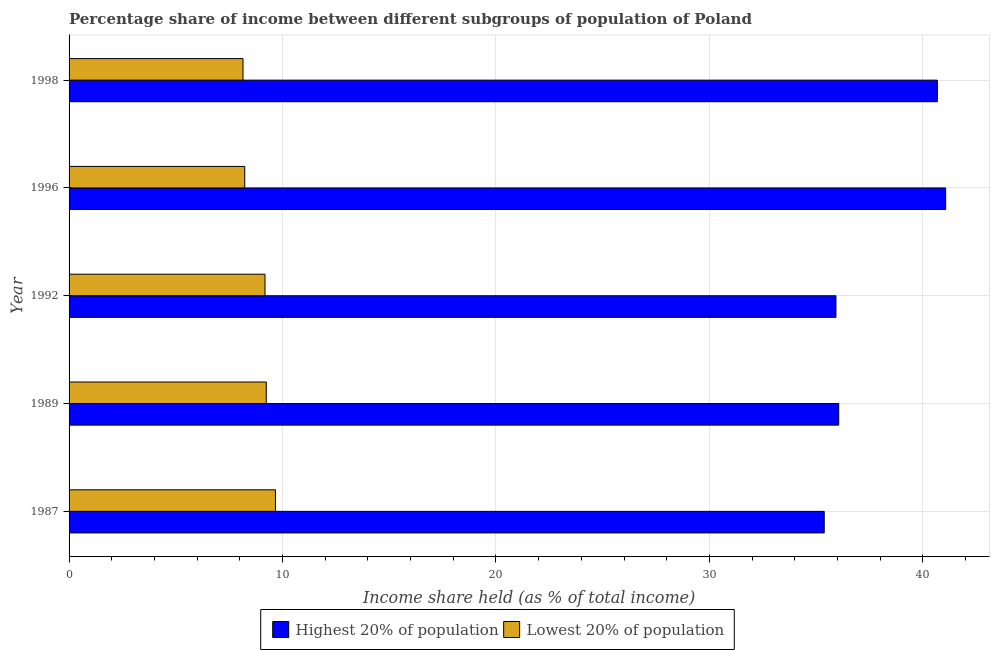How many different coloured bars are there?
Make the answer very short. 2. Are the number of bars on each tick of the Y-axis equal?
Keep it short and to the point. Yes. How many bars are there on the 1st tick from the top?
Your answer should be compact. 2. How many bars are there on the 3rd tick from the bottom?
Your answer should be very brief. 2. What is the income share held by highest 20% of the population in 1987?
Give a very brief answer. 35.38. Across all years, what is the maximum income share held by lowest 20% of the population?
Offer a very short reply. 9.67. Across all years, what is the minimum income share held by highest 20% of the population?
Your answer should be very brief. 35.38. What is the total income share held by highest 20% of the population in the graph?
Make the answer very short. 189.12. What is the difference between the income share held by highest 20% of the population in 1998 and the income share held by lowest 20% of the population in 1987?
Provide a short and direct response. 31.01. What is the average income share held by highest 20% of the population per year?
Your response must be concise. 37.82. In the year 1992, what is the difference between the income share held by highest 20% of the population and income share held by lowest 20% of the population?
Offer a very short reply. 26.75. Is the income share held by highest 20% of the population in 1987 less than that in 1998?
Make the answer very short. Yes. What is the difference between the highest and the second highest income share held by highest 20% of the population?
Give a very brief answer. 0.39. What is the difference between the highest and the lowest income share held by lowest 20% of the population?
Your answer should be compact. 1.52. In how many years, is the income share held by highest 20% of the population greater than the average income share held by highest 20% of the population taken over all years?
Ensure brevity in your answer.  2. What does the 1st bar from the top in 1992 represents?
Your response must be concise. Lowest 20% of population. What does the 2nd bar from the bottom in 1989 represents?
Make the answer very short. Lowest 20% of population. How many bars are there?
Give a very brief answer. 10. How many years are there in the graph?
Provide a succinct answer. 5. Where does the legend appear in the graph?
Ensure brevity in your answer.  Bottom center. How many legend labels are there?
Provide a short and direct response. 2. How are the legend labels stacked?
Your answer should be compact. Horizontal. What is the title of the graph?
Offer a terse response. Percentage share of income between different subgroups of population of Poland. Does "Travel services" appear as one of the legend labels in the graph?
Give a very brief answer. No. What is the label or title of the X-axis?
Offer a terse response. Income share held (as % of total income). What is the Income share held (as % of total income) of Highest 20% of population in 1987?
Make the answer very short. 35.38. What is the Income share held (as % of total income) in Lowest 20% of population in 1987?
Keep it short and to the point. 9.67. What is the Income share held (as % of total income) in Highest 20% of population in 1989?
Give a very brief answer. 36.06. What is the Income share held (as % of total income) in Lowest 20% of population in 1989?
Offer a terse response. 9.24. What is the Income share held (as % of total income) in Highest 20% of population in 1992?
Provide a succinct answer. 35.93. What is the Income share held (as % of total income) of Lowest 20% of population in 1992?
Give a very brief answer. 9.18. What is the Income share held (as % of total income) in Highest 20% of population in 1996?
Offer a terse response. 41.07. What is the Income share held (as % of total income) of Lowest 20% of population in 1996?
Keep it short and to the point. 8.23. What is the Income share held (as % of total income) of Highest 20% of population in 1998?
Your answer should be very brief. 40.68. What is the Income share held (as % of total income) of Lowest 20% of population in 1998?
Your response must be concise. 8.15. Across all years, what is the maximum Income share held (as % of total income) in Highest 20% of population?
Give a very brief answer. 41.07. Across all years, what is the maximum Income share held (as % of total income) of Lowest 20% of population?
Your response must be concise. 9.67. Across all years, what is the minimum Income share held (as % of total income) in Highest 20% of population?
Offer a terse response. 35.38. Across all years, what is the minimum Income share held (as % of total income) of Lowest 20% of population?
Your response must be concise. 8.15. What is the total Income share held (as % of total income) in Highest 20% of population in the graph?
Keep it short and to the point. 189.12. What is the total Income share held (as % of total income) in Lowest 20% of population in the graph?
Offer a terse response. 44.47. What is the difference between the Income share held (as % of total income) of Highest 20% of population in 1987 and that in 1989?
Offer a terse response. -0.68. What is the difference between the Income share held (as % of total income) in Lowest 20% of population in 1987 and that in 1989?
Provide a short and direct response. 0.43. What is the difference between the Income share held (as % of total income) in Highest 20% of population in 1987 and that in 1992?
Ensure brevity in your answer.  -0.55. What is the difference between the Income share held (as % of total income) of Lowest 20% of population in 1987 and that in 1992?
Your answer should be very brief. 0.49. What is the difference between the Income share held (as % of total income) in Highest 20% of population in 1987 and that in 1996?
Provide a short and direct response. -5.69. What is the difference between the Income share held (as % of total income) of Lowest 20% of population in 1987 and that in 1996?
Your answer should be very brief. 1.44. What is the difference between the Income share held (as % of total income) of Lowest 20% of population in 1987 and that in 1998?
Make the answer very short. 1.52. What is the difference between the Income share held (as % of total income) of Highest 20% of population in 1989 and that in 1992?
Your answer should be very brief. 0.13. What is the difference between the Income share held (as % of total income) in Lowest 20% of population in 1989 and that in 1992?
Your answer should be compact. 0.06. What is the difference between the Income share held (as % of total income) in Highest 20% of population in 1989 and that in 1996?
Ensure brevity in your answer.  -5.01. What is the difference between the Income share held (as % of total income) in Lowest 20% of population in 1989 and that in 1996?
Your answer should be very brief. 1.01. What is the difference between the Income share held (as % of total income) of Highest 20% of population in 1989 and that in 1998?
Make the answer very short. -4.62. What is the difference between the Income share held (as % of total income) in Lowest 20% of population in 1989 and that in 1998?
Your answer should be very brief. 1.09. What is the difference between the Income share held (as % of total income) in Highest 20% of population in 1992 and that in 1996?
Provide a succinct answer. -5.14. What is the difference between the Income share held (as % of total income) of Highest 20% of population in 1992 and that in 1998?
Offer a very short reply. -4.75. What is the difference between the Income share held (as % of total income) in Highest 20% of population in 1996 and that in 1998?
Keep it short and to the point. 0.39. What is the difference between the Income share held (as % of total income) in Lowest 20% of population in 1996 and that in 1998?
Your response must be concise. 0.08. What is the difference between the Income share held (as % of total income) of Highest 20% of population in 1987 and the Income share held (as % of total income) of Lowest 20% of population in 1989?
Ensure brevity in your answer.  26.14. What is the difference between the Income share held (as % of total income) in Highest 20% of population in 1987 and the Income share held (as % of total income) in Lowest 20% of population in 1992?
Provide a short and direct response. 26.2. What is the difference between the Income share held (as % of total income) of Highest 20% of population in 1987 and the Income share held (as % of total income) of Lowest 20% of population in 1996?
Offer a terse response. 27.15. What is the difference between the Income share held (as % of total income) of Highest 20% of population in 1987 and the Income share held (as % of total income) of Lowest 20% of population in 1998?
Ensure brevity in your answer.  27.23. What is the difference between the Income share held (as % of total income) in Highest 20% of population in 1989 and the Income share held (as % of total income) in Lowest 20% of population in 1992?
Provide a succinct answer. 26.88. What is the difference between the Income share held (as % of total income) in Highest 20% of population in 1989 and the Income share held (as % of total income) in Lowest 20% of population in 1996?
Your response must be concise. 27.83. What is the difference between the Income share held (as % of total income) in Highest 20% of population in 1989 and the Income share held (as % of total income) in Lowest 20% of population in 1998?
Your answer should be compact. 27.91. What is the difference between the Income share held (as % of total income) of Highest 20% of population in 1992 and the Income share held (as % of total income) of Lowest 20% of population in 1996?
Your answer should be compact. 27.7. What is the difference between the Income share held (as % of total income) in Highest 20% of population in 1992 and the Income share held (as % of total income) in Lowest 20% of population in 1998?
Give a very brief answer. 27.78. What is the difference between the Income share held (as % of total income) in Highest 20% of population in 1996 and the Income share held (as % of total income) in Lowest 20% of population in 1998?
Make the answer very short. 32.92. What is the average Income share held (as % of total income) of Highest 20% of population per year?
Your answer should be compact. 37.82. What is the average Income share held (as % of total income) of Lowest 20% of population per year?
Your answer should be compact. 8.89. In the year 1987, what is the difference between the Income share held (as % of total income) of Highest 20% of population and Income share held (as % of total income) of Lowest 20% of population?
Your answer should be compact. 25.71. In the year 1989, what is the difference between the Income share held (as % of total income) in Highest 20% of population and Income share held (as % of total income) in Lowest 20% of population?
Provide a short and direct response. 26.82. In the year 1992, what is the difference between the Income share held (as % of total income) in Highest 20% of population and Income share held (as % of total income) in Lowest 20% of population?
Give a very brief answer. 26.75. In the year 1996, what is the difference between the Income share held (as % of total income) of Highest 20% of population and Income share held (as % of total income) of Lowest 20% of population?
Your answer should be compact. 32.84. In the year 1998, what is the difference between the Income share held (as % of total income) of Highest 20% of population and Income share held (as % of total income) of Lowest 20% of population?
Your answer should be compact. 32.53. What is the ratio of the Income share held (as % of total income) of Highest 20% of population in 1987 to that in 1989?
Offer a terse response. 0.98. What is the ratio of the Income share held (as % of total income) of Lowest 20% of population in 1987 to that in 1989?
Your response must be concise. 1.05. What is the ratio of the Income share held (as % of total income) of Highest 20% of population in 1987 to that in 1992?
Your response must be concise. 0.98. What is the ratio of the Income share held (as % of total income) in Lowest 20% of population in 1987 to that in 1992?
Offer a very short reply. 1.05. What is the ratio of the Income share held (as % of total income) in Highest 20% of population in 1987 to that in 1996?
Your response must be concise. 0.86. What is the ratio of the Income share held (as % of total income) of Lowest 20% of population in 1987 to that in 1996?
Your answer should be compact. 1.18. What is the ratio of the Income share held (as % of total income) of Highest 20% of population in 1987 to that in 1998?
Offer a terse response. 0.87. What is the ratio of the Income share held (as % of total income) of Lowest 20% of population in 1987 to that in 1998?
Provide a succinct answer. 1.19. What is the ratio of the Income share held (as % of total income) of Lowest 20% of population in 1989 to that in 1992?
Keep it short and to the point. 1.01. What is the ratio of the Income share held (as % of total income) in Highest 20% of population in 1989 to that in 1996?
Make the answer very short. 0.88. What is the ratio of the Income share held (as % of total income) of Lowest 20% of population in 1989 to that in 1996?
Provide a succinct answer. 1.12. What is the ratio of the Income share held (as % of total income) in Highest 20% of population in 1989 to that in 1998?
Provide a succinct answer. 0.89. What is the ratio of the Income share held (as % of total income) of Lowest 20% of population in 1989 to that in 1998?
Your response must be concise. 1.13. What is the ratio of the Income share held (as % of total income) of Highest 20% of population in 1992 to that in 1996?
Ensure brevity in your answer.  0.87. What is the ratio of the Income share held (as % of total income) of Lowest 20% of population in 1992 to that in 1996?
Your answer should be compact. 1.12. What is the ratio of the Income share held (as % of total income) of Highest 20% of population in 1992 to that in 1998?
Offer a very short reply. 0.88. What is the ratio of the Income share held (as % of total income) of Lowest 20% of population in 1992 to that in 1998?
Give a very brief answer. 1.13. What is the ratio of the Income share held (as % of total income) of Highest 20% of population in 1996 to that in 1998?
Give a very brief answer. 1.01. What is the ratio of the Income share held (as % of total income) in Lowest 20% of population in 1996 to that in 1998?
Provide a short and direct response. 1.01. What is the difference between the highest and the second highest Income share held (as % of total income) in Highest 20% of population?
Make the answer very short. 0.39. What is the difference between the highest and the second highest Income share held (as % of total income) in Lowest 20% of population?
Offer a very short reply. 0.43. What is the difference between the highest and the lowest Income share held (as % of total income) of Highest 20% of population?
Provide a succinct answer. 5.69. What is the difference between the highest and the lowest Income share held (as % of total income) of Lowest 20% of population?
Provide a short and direct response. 1.52. 